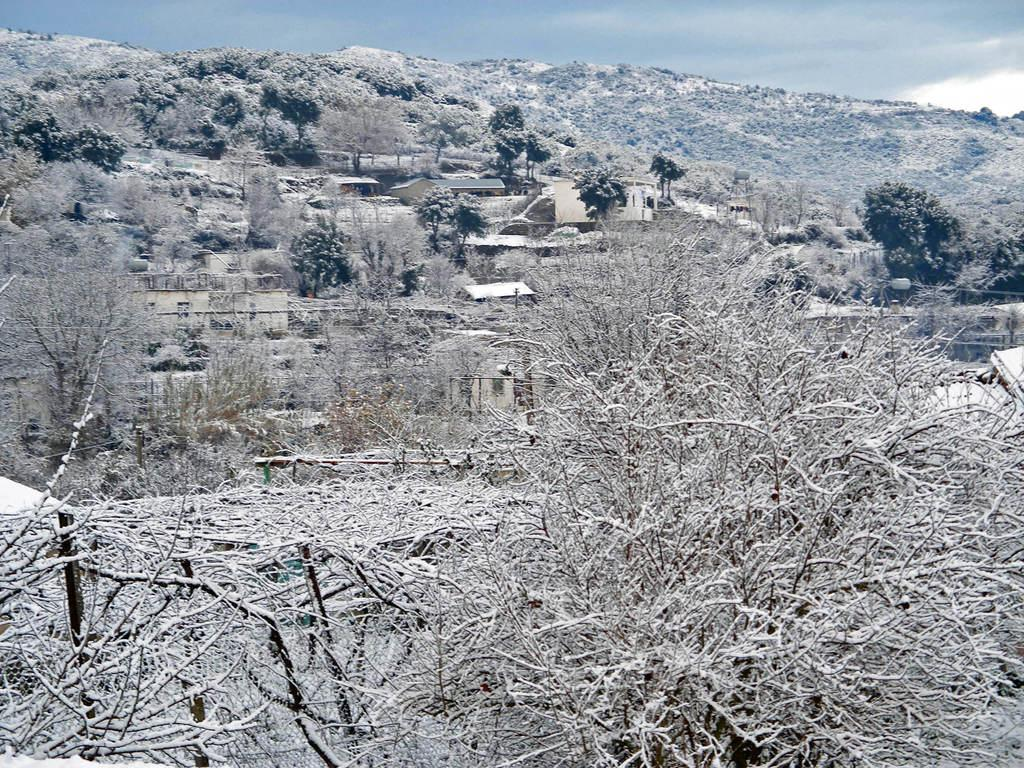What is the main subject of the image? The main subject of the image is a dried tree surface. What is growing on the dried tree surface? There are plants on the dried tree surface. What can be seen in the background of the image? There is a hill and the sky visible in the background of the image. What is the condition of the sky in the image? Clouds are present in the sky. What type of wool is being spun on the dried tree surface in the image? There is no wool or spinning activity present in the image; it features a dried tree surface with plants. Can you see any spots on the dried tree surface in the image? There is no mention of spots on the dried tree surface in the provided facts, so it cannot be determined from the image. 